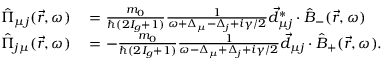<formula> <loc_0><loc_0><loc_500><loc_500>\begin{array} { r l } { \hat { \Pi } _ { \mu j } ( \vec { r } , \omega ) } & = \frac { m _ { 0 } } { \hbar { ( } 2 I _ { g } + 1 ) } \frac { 1 } { \omega + \Delta _ { \mu } - \Delta _ { j } + i \gamma / 2 } \vec { d } _ { \mu j } ^ { * } \cdot \hat { B } _ { - } ( \vec { r } , \omega ) } \\ { \hat { \Pi } _ { j \mu } ( \vec { r } , \omega ) } & = - \frac { m _ { 0 } } { \hbar { ( } 2 I _ { g } + 1 ) } \frac { 1 } { \omega - \Delta _ { \mu } + \Delta _ { j } + i \gamma / 2 } \vec { d } _ { \mu j } \cdot \hat { B } _ { + } ( \vec { r } , \omega ) . } \end{array}</formula> 